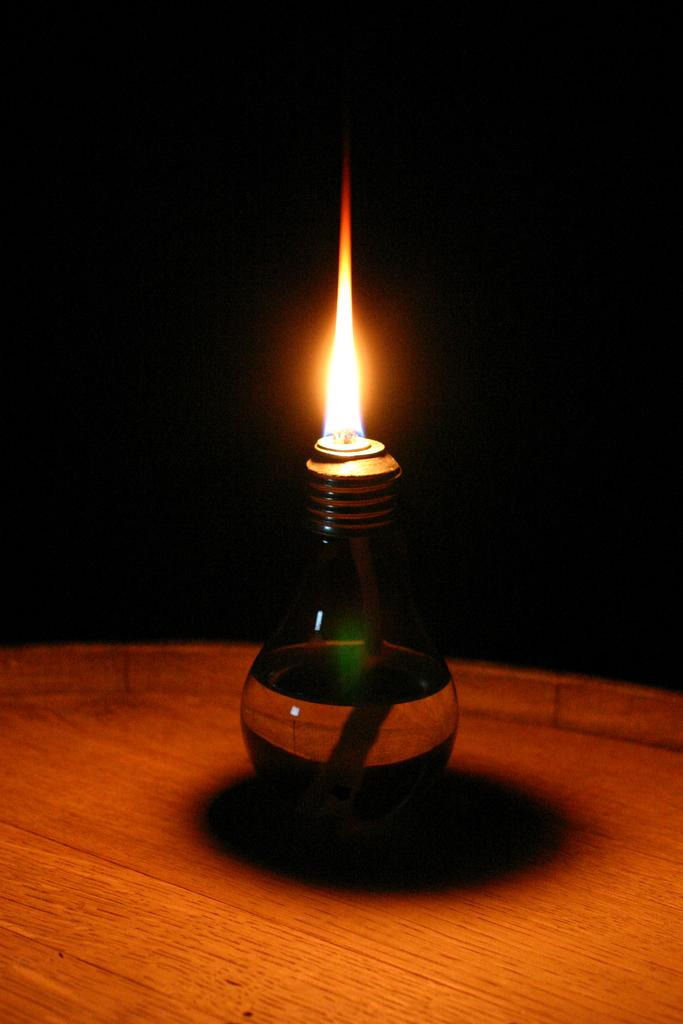What object can be seen in the image? There is a candle in the image. What is happening to the candle in the image? The candle has a flame. Where is the nearest park to the location of the candle in the image? There is no information about the location of the candle or the presence of a park in the image, so it cannot be determined. 